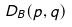<formula> <loc_0><loc_0><loc_500><loc_500>D _ { B } ( p , q )</formula> 